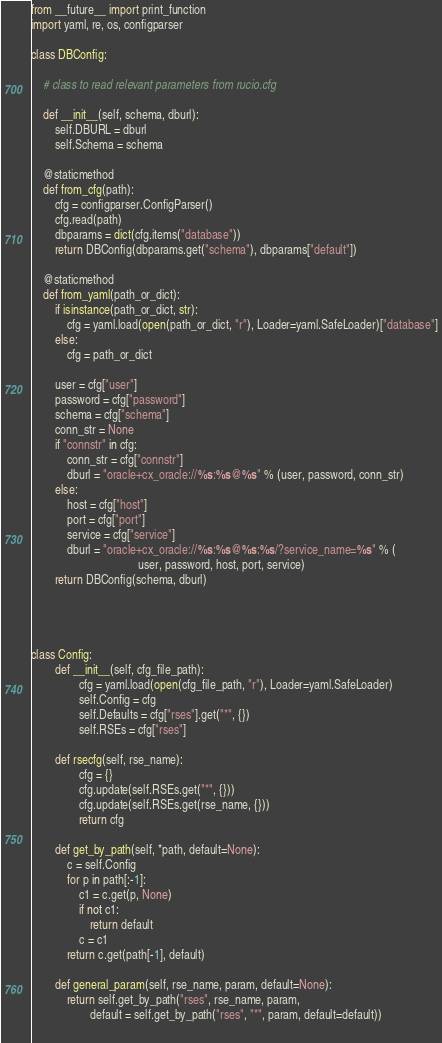<code> <loc_0><loc_0><loc_500><loc_500><_Python_>from __future__ import print_function
import yaml, re, os, configparser

class DBConfig:

	# class to read relevant parameters from rucio.cfg

    def __init__(self, schema, dburl):
        self.DBURL = dburl
        self.Schema = schema
    
    @staticmethod
    def from_cfg(path):
        cfg = configparser.ConfigParser()
        cfg.read(path)
        dbparams = dict(cfg.items("database"))
        return DBConfig(dbparams.get("schema"), dbparams["default"])
        
    @staticmethod
    def from_yaml(path_or_dict):
        if isinstance(path_or_dict, str):
            cfg = yaml.load(open(path_or_dict, "r"), Loader=yaml.SafeLoader)["database"]
        else:
            cfg = path_or_dict

        user = cfg["user"]
        password = cfg["password"]
        schema = cfg["schema"]
        conn_str = None
        if "connstr" in cfg:
            conn_str = cfg["connstr"]
            dburl = "oracle+cx_oracle://%s:%s@%s" % (user, password, conn_str)
        else:
            host = cfg["host"]
            port = cfg["port"]
            service = cfg["service"]
            dburl = "oracle+cx_oracle://%s:%s@%s:%s/?service_name=%s" % (
                                    user, password, host, port, service)
        return DBConfig(schema, dburl)
    
        
    

class Config:
        def __init__(self, cfg_file_path):
                cfg = yaml.load(open(cfg_file_path, "r"), Loader=yaml.SafeLoader)
                self.Config = cfg
                self.Defaults = cfg["rses"].get("*", {})
                self.RSEs = cfg["rses"]

        def rsecfg(self, rse_name):
                cfg = {}
                cfg.update(self.RSEs.get("*", {}))
                cfg.update(self.RSEs.get(rse_name, {}))
                return cfg

        def get_by_path(self, *path, default=None):
            c = self.Config
            for p in path[:-1]:
                c1 = c.get(p, None)
                if not c1:
                    return default
                c = c1
            return c.get(path[-1], default)

        def general_param(self, rse_name, param, default=None):
            return self.get_by_path("rses", rse_name, param, 
                    default = self.get_by_path("rses", "*", param, default=default))
                    </code> 